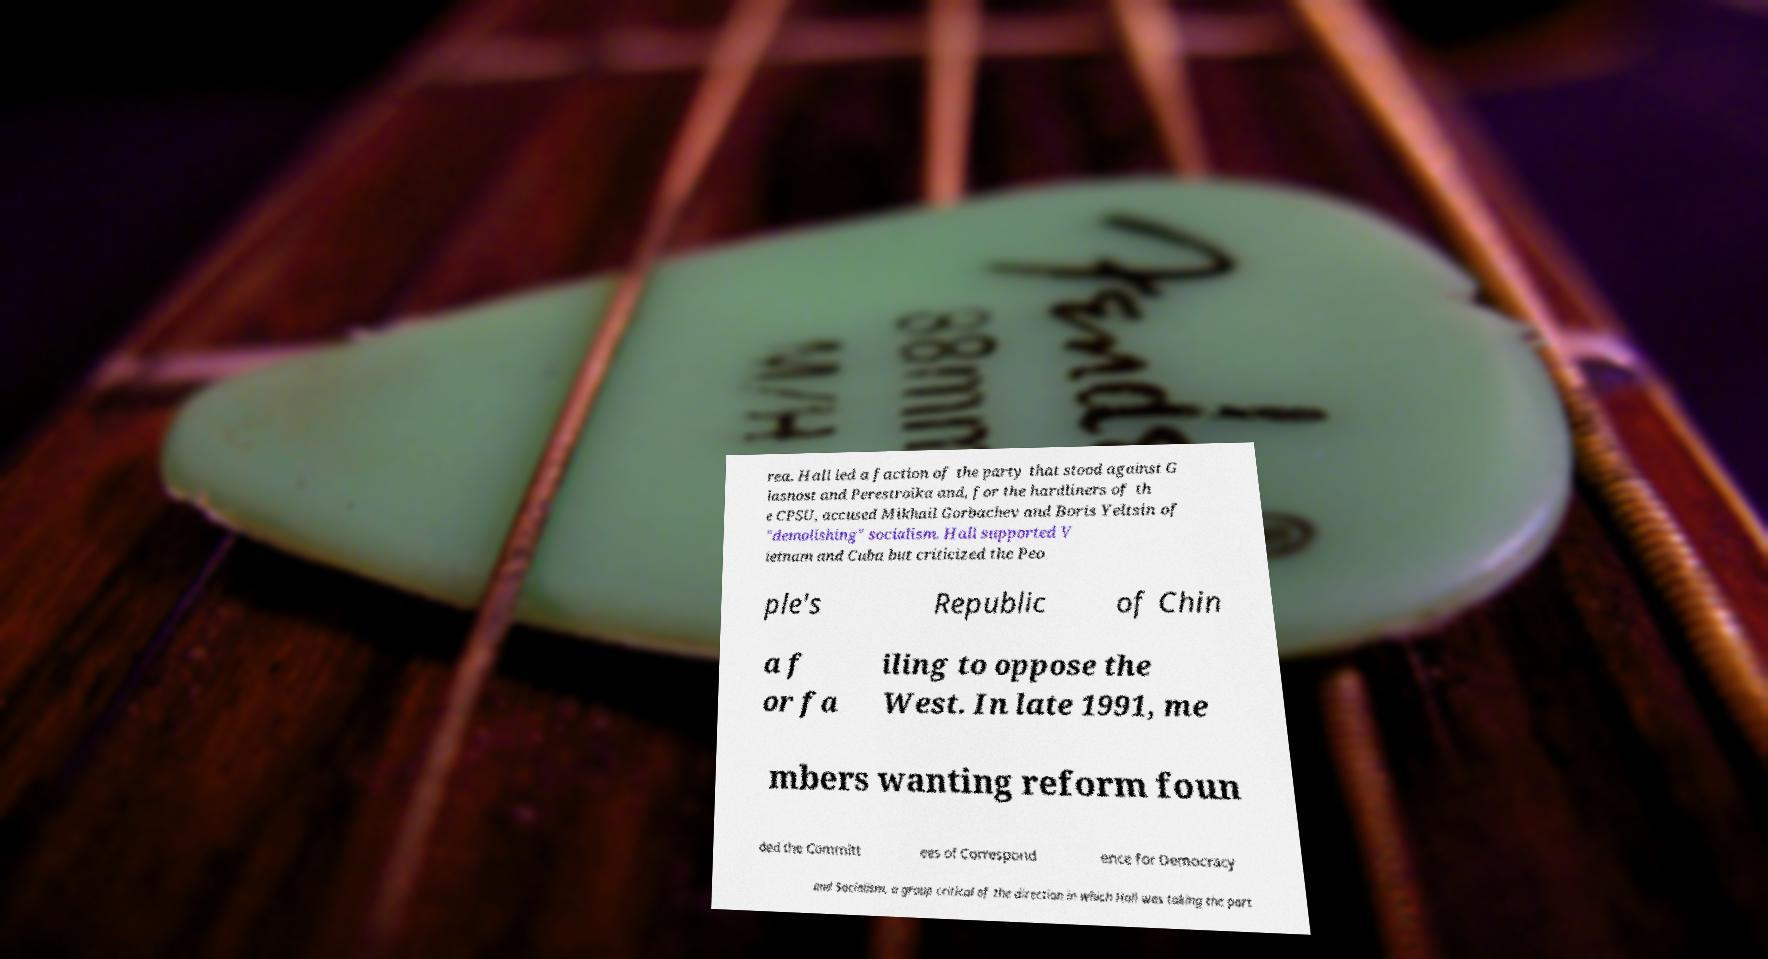There's text embedded in this image that I need extracted. Can you transcribe it verbatim? rea. Hall led a faction of the party that stood against G lasnost and Perestroika and, for the hardliners of th e CPSU, accused Mikhail Gorbachev and Boris Yeltsin of "demolishing" socialism. Hall supported V ietnam and Cuba but criticized the Peo ple's Republic of Chin a f or fa iling to oppose the West. In late 1991, me mbers wanting reform foun ded the Committ ees of Correspond ence for Democracy and Socialism, a group critical of the direction in which Hall was taking the part 